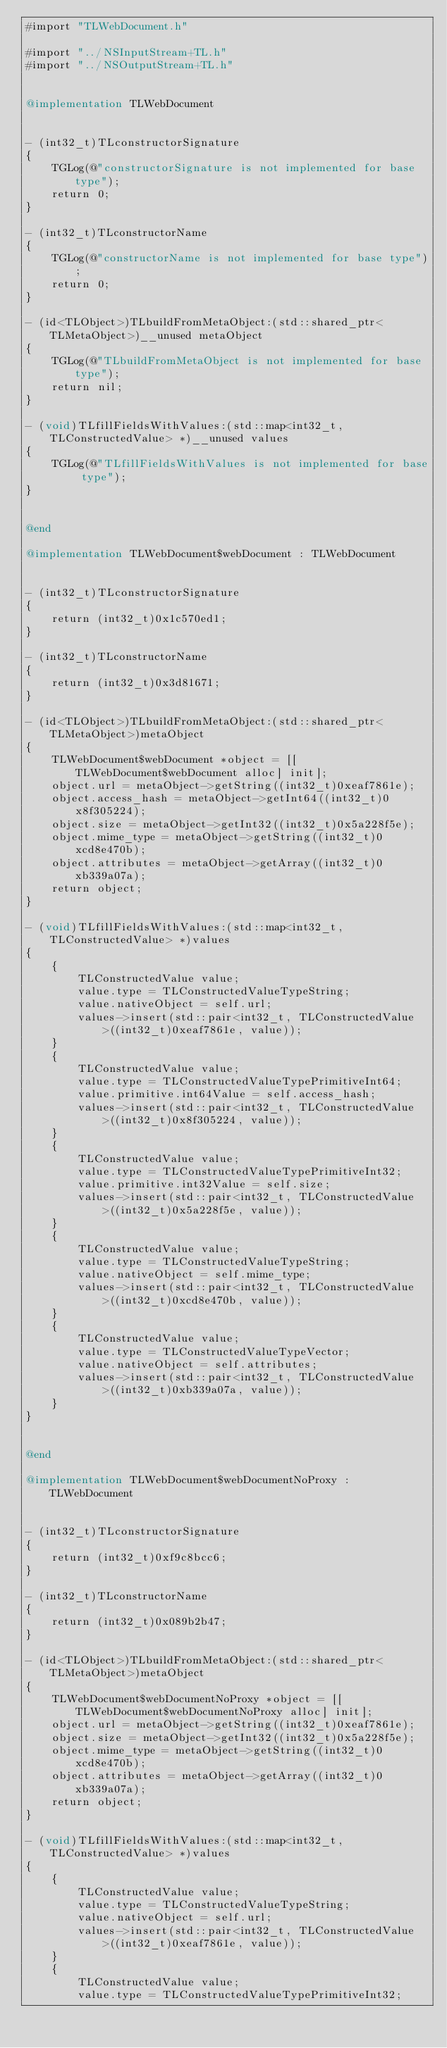<code> <loc_0><loc_0><loc_500><loc_500><_ObjectiveC_>#import "TLWebDocument.h"

#import "../NSInputStream+TL.h"
#import "../NSOutputStream+TL.h"


@implementation TLWebDocument


- (int32_t)TLconstructorSignature
{
    TGLog(@"constructorSignature is not implemented for base type");
    return 0;
}

- (int32_t)TLconstructorName
{
    TGLog(@"constructorName is not implemented for base type");
    return 0;
}

- (id<TLObject>)TLbuildFromMetaObject:(std::shared_ptr<TLMetaObject>)__unused metaObject
{
    TGLog(@"TLbuildFromMetaObject is not implemented for base type");
    return nil;
}

- (void)TLfillFieldsWithValues:(std::map<int32_t, TLConstructedValue> *)__unused values
{
    TGLog(@"TLfillFieldsWithValues is not implemented for base type");
}


@end

@implementation TLWebDocument$webDocument : TLWebDocument


- (int32_t)TLconstructorSignature
{
    return (int32_t)0x1c570ed1;
}

- (int32_t)TLconstructorName
{
    return (int32_t)0x3d81671;
}

- (id<TLObject>)TLbuildFromMetaObject:(std::shared_ptr<TLMetaObject>)metaObject
{
    TLWebDocument$webDocument *object = [[TLWebDocument$webDocument alloc] init];
    object.url = metaObject->getString((int32_t)0xeaf7861e);
    object.access_hash = metaObject->getInt64((int32_t)0x8f305224);
    object.size = metaObject->getInt32((int32_t)0x5a228f5e);
    object.mime_type = metaObject->getString((int32_t)0xcd8e470b);
    object.attributes = metaObject->getArray((int32_t)0xb339a07a);
    return object;
}

- (void)TLfillFieldsWithValues:(std::map<int32_t, TLConstructedValue> *)values
{
    {
        TLConstructedValue value;
        value.type = TLConstructedValueTypeString;
        value.nativeObject = self.url;
        values->insert(std::pair<int32_t, TLConstructedValue>((int32_t)0xeaf7861e, value));
    }
    {
        TLConstructedValue value;
        value.type = TLConstructedValueTypePrimitiveInt64;
        value.primitive.int64Value = self.access_hash;
        values->insert(std::pair<int32_t, TLConstructedValue>((int32_t)0x8f305224, value));
    }
    {
        TLConstructedValue value;
        value.type = TLConstructedValueTypePrimitiveInt32;
        value.primitive.int32Value = self.size;
        values->insert(std::pair<int32_t, TLConstructedValue>((int32_t)0x5a228f5e, value));
    }
    {
        TLConstructedValue value;
        value.type = TLConstructedValueTypeString;
        value.nativeObject = self.mime_type;
        values->insert(std::pair<int32_t, TLConstructedValue>((int32_t)0xcd8e470b, value));
    }
    {
        TLConstructedValue value;
        value.type = TLConstructedValueTypeVector;
        value.nativeObject = self.attributes;
        values->insert(std::pair<int32_t, TLConstructedValue>((int32_t)0xb339a07a, value));
    }
}


@end

@implementation TLWebDocument$webDocumentNoProxy : TLWebDocument


- (int32_t)TLconstructorSignature
{
    return (int32_t)0xf9c8bcc6;
}

- (int32_t)TLconstructorName
{
    return (int32_t)0x089b2b47;
}

- (id<TLObject>)TLbuildFromMetaObject:(std::shared_ptr<TLMetaObject>)metaObject
{
    TLWebDocument$webDocumentNoProxy *object = [[TLWebDocument$webDocumentNoProxy alloc] init];
    object.url = metaObject->getString((int32_t)0xeaf7861e);
    object.size = metaObject->getInt32((int32_t)0x5a228f5e);
    object.mime_type = metaObject->getString((int32_t)0xcd8e470b);
    object.attributes = metaObject->getArray((int32_t)0xb339a07a);
    return object;
}

- (void)TLfillFieldsWithValues:(std::map<int32_t, TLConstructedValue> *)values
{
    {
        TLConstructedValue value;
        value.type = TLConstructedValueTypeString;
        value.nativeObject = self.url;
        values->insert(std::pair<int32_t, TLConstructedValue>((int32_t)0xeaf7861e, value));
    }
    {
        TLConstructedValue value;
        value.type = TLConstructedValueTypePrimitiveInt32;</code> 